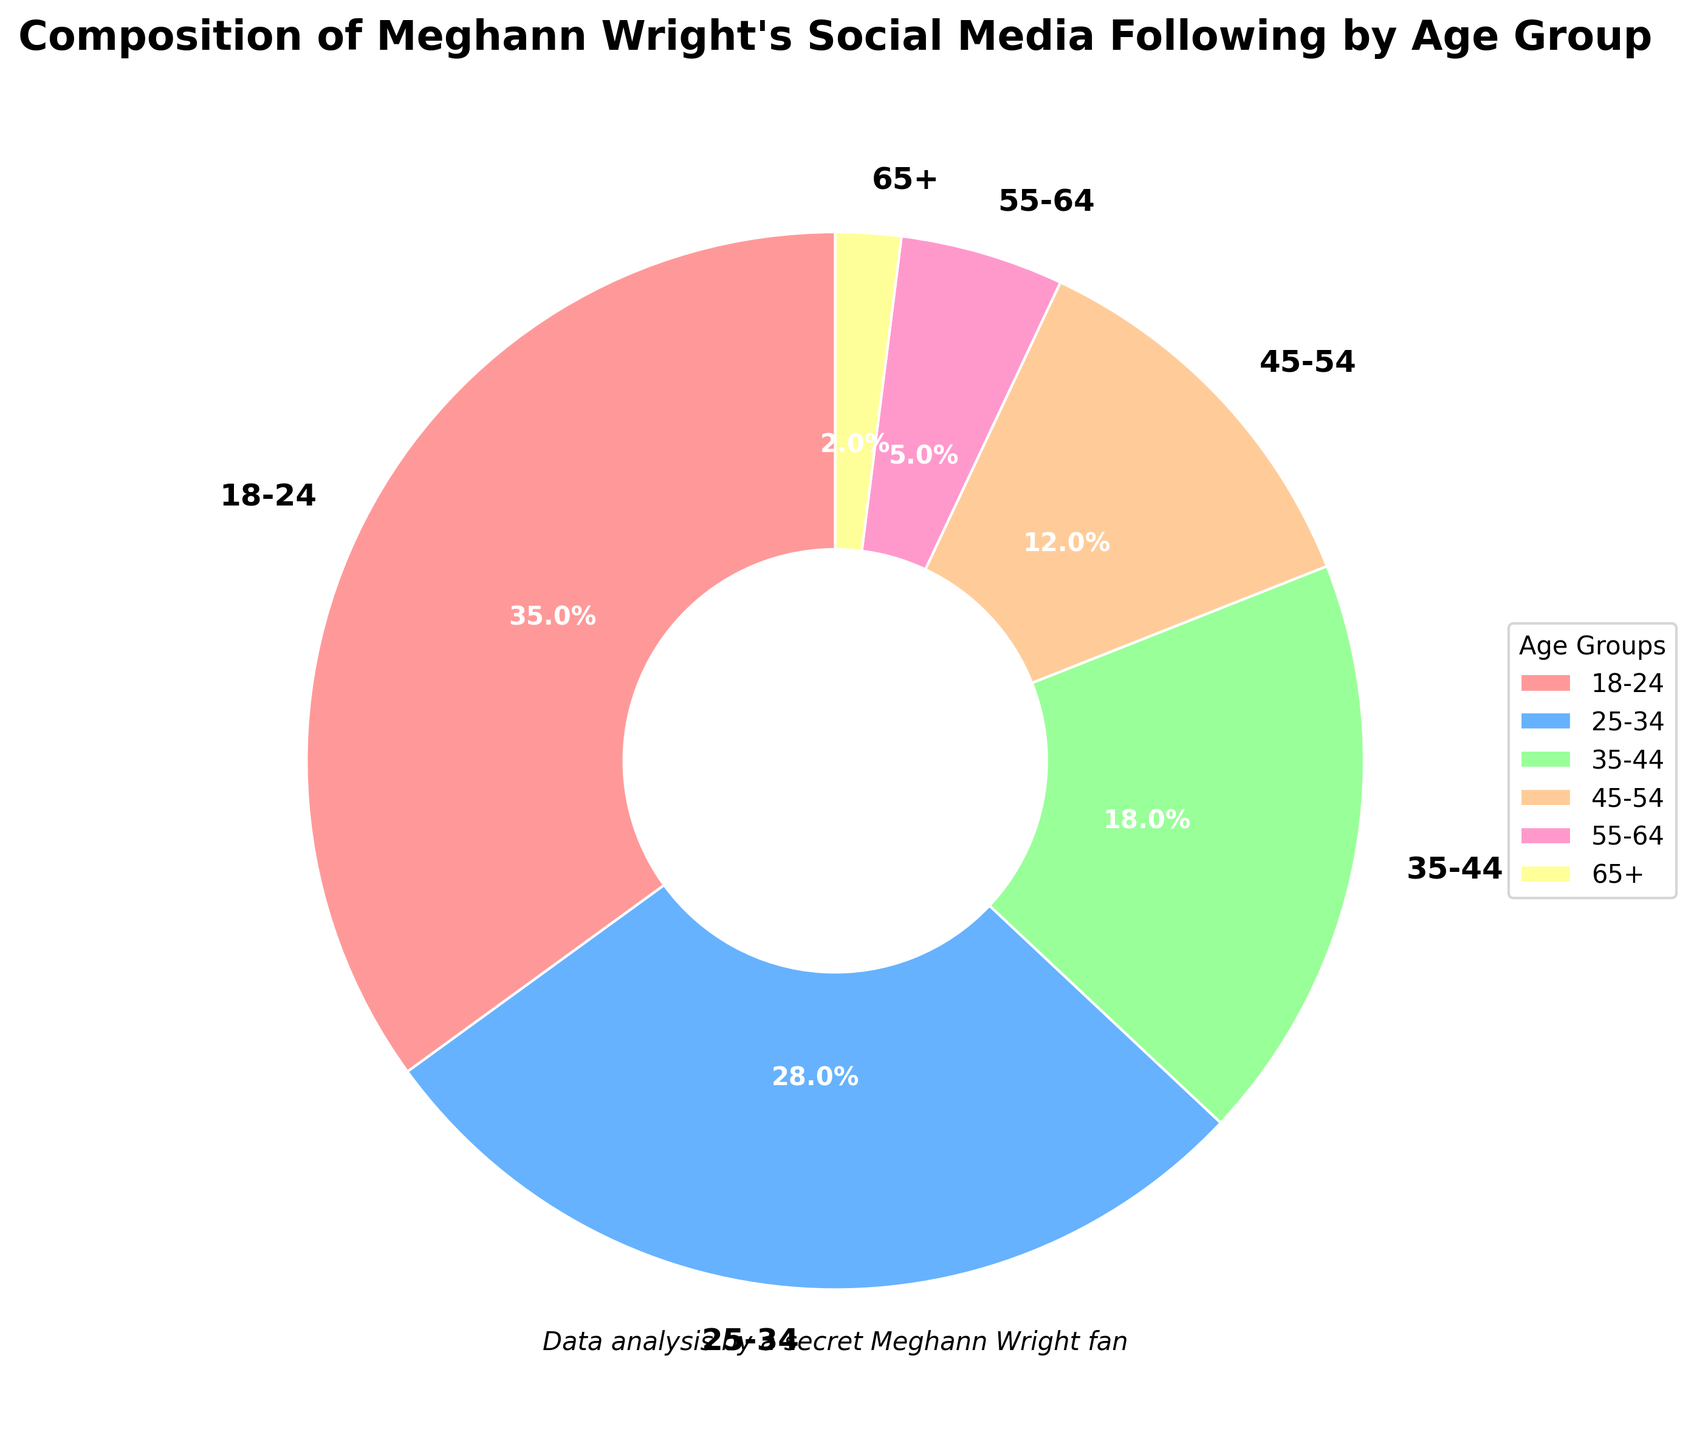What percentage of Meghann Wright’s social media following is below 35 years old? To find this, add the percentages of the 18-24 and 25-34 age groups: 35% + 28% = 63%.
Answer: 63% Which age group has the smallest following? The age group with the smallest percentage in the pie chart is 65+, with 2%.
Answer: 65+ How does the combined percentage of followers aged 45 and above compare to the percentage of followers aged 18-24? Add the percentages of the 45-54, 55-64, and 65+ age groups: 12% + 5% + 2% = 19%. Compare this to the 18-24 age group, which is 35%. 19% is less than 35%.
Answer: Less What is the visual color associated with the 25-34 age group? From the pie chart, the 25-34 age group is represented by a blue section.
Answer: Blue Which age group represents the second largest segment of Meghann Wright's social media following? The second largest wedge after 18-24 (35%) is the 25-34 age group, which is 28%.
Answer: 25-34 What percentage of Meghann Wright's social media following is 35 years old and above? To find this, add the percentages of the 35-44, 45-54, 55-64, and 65+ age groups: 18% + 12% + 5% + 2% = 37%.
Answer: 37% List the age groups in descending order based on their percentage of Meghann Wright's social media following. The age groups ordered by percentage are 18-24 (35%), 25-34 (28%), 35-44 (18%), 45-54 (12%), 55-64 (5%), 65+ (2%).
Answer: 18-24, 25-34, 35-44, 45-54, 55-64, 65+ Is the percentage of followers aged 55-64 greater than those aged 35-44? Compare the percentages: 5% for 55-64 and 18% for 35-44. 5% is not greater than 18%.
Answer: No What visual attribute indicates the relative size of the age groups in the pie chart? The size of the wedge or segment in the pie chart indicates the relative size of the age groups. Larger wedges correspond to higher percentages.
Answer: Wedge size What combination of three age groups adds up to more than half of Meghann Wright’s social media following? Adding the percentages of the three largest groups: 18-24 (35%), 25-34 (28%), and 35-44 (18%) equals 35% + 28% + 18% = 81%, which is more than half.
Answer: 18-24, 25-34, 35-44 